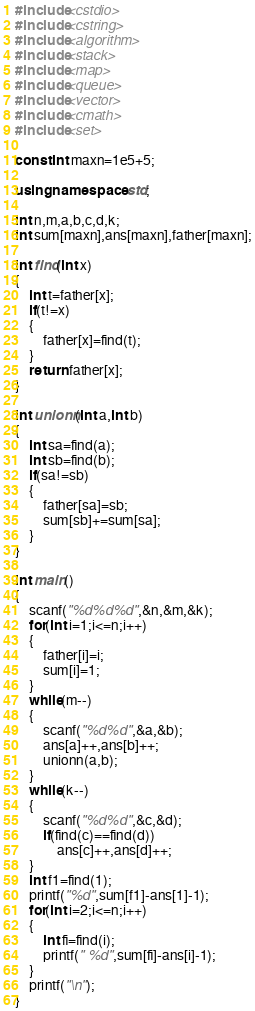Convert code to text. <code><loc_0><loc_0><loc_500><loc_500><_C++_>#include<cstdio>
#include<cstring>
#include<algorithm>
#include<stack>
#include<map>
#include<queue>
#include<vector>
#include<cmath>
#include<set>

const int maxn=1e5+5;

using namespace std;

int n,m,a,b,c,d,k;
int sum[maxn],ans[maxn],father[maxn];

int find(int x)
{
    int t=father[x];
    if(t!=x)
    {
        father[x]=find(t);
    }
    return father[x];
}

int unionn(int a,int b)
{
    int sa=find(a);
    int sb=find(b);
    if(sa!=sb)
    {
        father[sa]=sb;
        sum[sb]+=sum[sa];
    }
}

int main()
{
    scanf("%d%d%d",&n,&m,&k);
    for(int i=1;i<=n;i++)
    {
        father[i]=i;
        sum[i]=1;
    }
    while(m--)
    {
        scanf("%d%d",&a,&b);
        ans[a]++,ans[b]++;
        unionn(a,b);
    }
    while(k--)
    {
        scanf("%d%d",&c,&d);
        if(find(c)==find(d))
            ans[c]++,ans[d]++;
    }
    int f1=find(1);
    printf("%d",sum[f1]-ans[1]-1);
    for(int i=2;i<=n;i++)
    {
        int fi=find(i);
        printf(" %d",sum[fi]-ans[i]-1);
    }
    printf("\n");
}</code> 